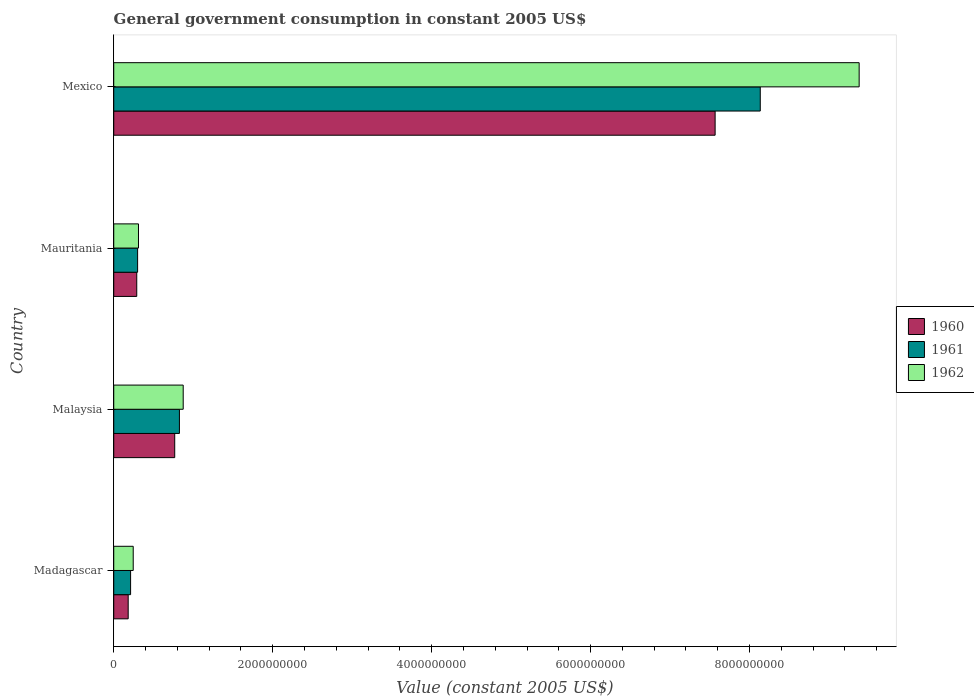How many different coloured bars are there?
Ensure brevity in your answer.  3. Are the number of bars per tick equal to the number of legend labels?
Give a very brief answer. Yes. Are the number of bars on each tick of the Y-axis equal?
Give a very brief answer. Yes. How many bars are there on the 3rd tick from the bottom?
Your answer should be very brief. 3. What is the label of the 3rd group of bars from the top?
Offer a terse response. Malaysia. What is the government conusmption in 1960 in Malaysia?
Provide a short and direct response. 7.67e+08. Across all countries, what is the maximum government conusmption in 1962?
Your answer should be compact. 9.38e+09. Across all countries, what is the minimum government conusmption in 1961?
Offer a terse response. 2.12e+08. In which country was the government conusmption in 1960 minimum?
Your answer should be very brief. Madagascar. What is the total government conusmption in 1962 in the graph?
Your answer should be compact. 1.08e+1. What is the difference between the government conusmption in 1960 in Malaysia and that in Mauritania?
Provide a succinct answer. 4.78e+08. What is the difference between the government conusmption in 1962 in Mauritania and the government conusmption in 1961 in Madagascar?
Your response must be concise. 9.93e+07. What is the average government conusmption in 1962 per country?
Provide a short and direct response. 2.70e+09. What is the difference between the government conusmption in 1962 and government conusmption in 1960 in Mexico?
Make the answer very short. 1.81e+09. What is the ratio of the government conusmption in 1960 in Madagascar to that in Mexico?
Offer a terse response. 0.02. Is the government conusmption in 1961 in Madagascar less than that in Mauritania?
Provide a short and direct response. Yes. Is the difference between the government conusmption in 1962 in Madagascar and Mexico greater than the difference between the government conusmption in 1960 in Madagascar and Mexico?
Provide a short and direct response. No. What is the difference between the highest and the second highest government conusmption in 1961?
Ensure brevity in your answer.  7.31e+09. What is the difference between the highest and the lowest government conusmption in 1962?
Your response must be concise. 9.13e+09. In how many countries, is the government conusmption in 1961 greater than the average government conusmption in 1961 taken over all countries?
Give a very brief answer. 1. What does the 3rd bar from the top in Mexico represents?
Provide a short and direct response. 1960. What does the 3rd bar from the bottom in Madagascar represents?
Keep it short and to the point. 1962. How many bars are there?
Ensure brevity in your answer.  12. Does the graph contain grids?
Give a very brief answer. No. Where does the legend appear in the graph?
Provide a short and direct response. Center right. How many legend labels are there?
Your answer should be very brief. 3. How are the legend labels stacked?
Provide a succinct answer. Vertical. What is the title of the graph?
Keep it short and to the point. General government consumption in constant 2005 US$. Does "1995" appear as one of the legend labels in the graph?
Provide a succinct answer. No. What is the label or title of the X-axis?
Your response must be concise. Value (constant 2005 US$). What is the Value (constant 2005 US$) of 1960 in Madagascar?
Your response must be concise. 1.82e+08. What is the Value (constant 2005 US$) of 1961 in Madagascar?
Provide a short and direct response. 2.12e+08. What is the Value (constant 2005 US$) in 1962 in Madagascar?
Offer a very short reply. 2.45e+08. What is the Value (constant 2005 US$) in 1960 in Malaysia?
Offer a terse response. 7.67e+08. What is the Value (constant 2005 US$) of 1961 in Malaysia?
Give a very brief answer. 8.26e+08. What is the Value (constant 2005 US$) in 1962 in Malaysia?
Make the answer very short. 8.74e+08. What is the Value (constant 2005 US$) in 1960 in Mauritania?
Provide a short and direct response. 2.89e+08. What is the Value (constant 2005 US$) in 1961 in Mauritania?
Your response must be concise. 3.00e+08. What is the Value (constant 2005 US$) of 1962 in Mauritania?
Ensure brevity in your answer.  3.11e+08. What is the Value (constant 2005 US$) of 1960 in Mexico?
Provide a succinct answer. 7.57e+09. What is the Value (constant 2005 US$) in 1961 in Mexico?
Offer a very short reply. 8.13e+09. What is the Value (constant 2005 US$) in 1962 in Mexico?
Provide a succinct answer. 9.38e+09. Across all countries, what is the maximum Value (constant 2005 US$) of 1960?
Ensure brevity in your answer.  7.57e+09. Across all countries, what is the maximum Value (constant 2005 US$) in 1961?
Your answer should be very brief. 8.13e+09. Across all countries, what is the maximum Value (constant 2005 US$) of 1962?
Your answer should be compact. 9.38e+09. Across all countries, what is the minimum Value (constant 2005 US$) in 1960?
Offer a very short reply. 1.82e+08. Across all countries, what is the minimum Value (constant 2005 US$) of 1961?
Give a very brief answer. 2.12e+08. Across all countries, what is the minimum Value (constant 2005 US$) in 1962?
Your answer should be compact. 2.45e+08. What is the total Value (constant 2005 US$) of 1960 in the graph?
Make the answer very short. 8.81e+09. What is the total Value (constant 2005 US$) of 1961 in the graph?
Make the answer very short. 9.47e+09. What is the total Value (constant 2005 US$) of 1962 in the graph?
Provide a succinct answer. 1.08e+1. What is the difference between the Value (constant 2005 US$) of 1960 in Madagascar and that in Malaysia?
Provide a succinct answer. -5.85e+08. What is the difference between the Value (constant 2005 US$) of 1961 in Madagascar and that in Malaysia?
Your answer should be compact. -6.14e+08. What is the difference between the Value (constant 2005 US$) in 1962 in Madagascar and that in Malaysia?
Your response must be concise. -6.29e+08. What is the difference between the Value (constant 2005 US$) in 1960 in Madagascar and that in Mauritania?
Ensure brevity in your answer.  -1.08e+08. What is the difference between the Value (constant 2005 US$) in 1961 in Madagascar and that in Mauritania?
Offer a very short reply. -8.84e+07. What is the difference between the Value (constant 2005 US$) in 1962 in Madagascar and that in Mauritania?
Ensure brevity in your answer.  -6.62e+07. What is the difference between the Value (constant 2005 US$) in 1960 in Madagascar and that in Mexico?
Provide a succinct answer. -7.38e+09. What is the difference between the Value (constant 2005 US$) in 1961 in Madagascar and that in Mexico?
Your answer should be compact. -7.92e+09. What is the difference between the Value (constant 2005 US$) in 1962 in Madagascar and that in Mexico?
Your response must be concise. -9.13e+09. What is the difference between the Value (constant 2005 US$) in 1960 in Malaysia and that in Mauritania?
Offer a very short reply. 4.78e+08. What is the difference between the Value (constant 2005 US$) in 1961 in Malaysia and that in Mauritania?
Provide a succinct answer. 5.26e+08. What is the difference between the Value (constant 2005 US$) of 1962 in Malaysia and that in Mauritania?
Offer a terse response. 5.63e+08. What is the difference between the Value (constant 2005 US$) in 1960 in Malaysia and that in Mexico?
Provide a short and direct response. -6.80e+09. What is the difference between the Value (constant 2005 US$) of 1961 in Malaysia and that in Mexico?
Give a very brief answer. -7.31e+09. What is the difference between the Value (constant 2005 US$) in 1962 in Malaysia and that in Mexico?
Your answer should be compact. -8.50e+09. What is the difference between the Value (constant 2005 US$) of 1960 in Mauritania and that in Mexico?
Ensure brevity in your answer.  -7.28e+09. What is the difference between the Value (constant 2005 US$) in 1961 in Mauritania and that in Mexico?
Make the answer very short. -7.83e+09. What is the difference between the Value (constant 2005 US$) in 1962 in Mauritania and that in Mexico?
Your answer should be compact. -9.07e+09. What is the difference between the Value (constant 2005 US$) in 1960 in Madagascar and the Value (constant 2005 US$) in 1961 in Malaysia?
Your answer should be compact. -6.45e+08. What is the difference between the Value (constant 2005 US$) of 1960 in Madagascar and the Value (constant 2005 US$) of 1962 in Malaysia?
Provide a short and direct response. -6.92e+08. What is the difference between the Value (constant 2005 US$) of 1961 in Madagascar and the Value (constant 2005 US$) of 1962 in Malaysia?
Provide a short and direct response. -6.62e+08. What is the difference between the Value (constant 2005 US$) in 1960 in Madagascar and the Value (constant 2005 US$) in 1961 in Mauritania?
Offer a terse response. -1.19e+08. What is the difference between the Value (constant 2005 US$) in 1960 in Madagascar and the Value (constant 2005 US$) in 1962 in Mauritania?
Your answer should be compact. -1.30e+08. What is the difference between the Value (constant 2005 US$) of 1961 in Madagascar and the Value (constant 2005 US$) of 1962 in Mauritania?
Offer a terse response. -9.93e+07. What is the difference between the Value (constant 2005 US$) in 1960 in Madagascar and the Value (constant 2005 US$) in 1961 in Mexico?
Provide a succinct answer. -7.95e+09. What is the difference between the Value (constant 2005 US$) in 1960 in Madagascar and the Value (constant 2005 US$) in 1962 in Mexico?
Offer a terse response. -9.20e+09. What is the difference between the Value (constant 2005 US$) of 1961 in Madagascar and the Value (constant 2005 US$) of 1962 in Mexico?
Provide a short and direct response. -9.17e+09. What is the difference between the Value (constant 2005 US$) in 1960 in Malaysia and the Value (constant 2005 US$) in 1961 in Mauritania?
Your answer should be very brief. 4.67e+08. What is the difference between the Value (constant 2005 US$) in 1960 in Malaysia and the Value (constant 2005 US$) in 1962 in Mauritania?
Provide a short and direct response. 4.56e+08. What is the difference between the Value (constant 2005 US$) in 1961 in Malaysia and the Value (constant 2005 US$) in 1962 in Mauritania?
Provide a short and direct response. 5.15e+08. What is the difference between the Value (constant 2005 US$) in 1960 in Malaysia and the Value (constant 2005 US$) in 1961 in Mexico?
Offer a terse response. -7.37e+09. What is the difference between the Value (constant 2005 US$) of 1960 in Malaysia and the Value (constant 2005 US$) of 1962 in Mexico?
Keep it short and to the point. -8.61e+09. What is the difference between the Value (constant 2005 US$) in 1961 in Malaysia and the Value (constant 2005 US$) in 1962 in Mexico?
Provide a succinct answer. -8.55e+09. What is the difference between the Value (constant 2005 US$) of 1960 in Mauritania and the Value (constant 2005 US$) of 1961 in Mexico?
Provide a succinct answer. -7.85e+09. What is the difference between the Value (constant 2005 US$) in 1960 in Mauritania and the Value (constant 2005 US$) in 1962 in Mexico?
Offer a very short reply. -9.09e+09. What is the difference between the Value (constant 2005 US$) of 1961 in Mauritania and the Value (constant 2005 US$) of 1962 in Mexico?
Give a very brief answer. -9.08e+09. What is the average Value (constant 2005 US$) in 1960 per country?
Make the answer very short. 2.20e+09. What is the average Value (constant 2005 US$) in 1961 per country?
Give a very brief answer. 2.37e+09. What is the average Value (constant 2005 US$) in 1962 per country?
Provide a succinct answer. 2.70e+09. What is the difference between the Value (constant 2005 US$) in 1960 and Value (constant 2005 US$) in 1961 in Madagascar?
Your answer should be very brief. -3.02e+07. What is the difference between the Value (constant 2005 US$) in 1960 and Value (constant 2005 US$) in 1962 in Madagascar?
Provide a succinct answer. -6.34e+07. What is the difference between the Value (constant 2005 US$) in 1961 and Value (constant 2005 US$) in 1962 in Madagascar?
Provide a short and direct response. -3.32e+07. What is the difference between the Value (constant 2005 US$) of 1960 and Value (constant 2005 US$) of 1961 in Malaysia?
Give a very brief answer. -5.92e+07. What is the difference between the Value (constant 2005 US$) in 1960 and Value (constant 2005 US$) in 1962 in Malaysia?
Your response must be concise. -1.07e+08. What is the difference between the Value (constant 2005 US$) in 1961 and Value (constant 2005 US$) in 1962 in Malaysia?
Ensure brevity in your answer.  -4.75e+07. What is the difference between the Value (constant 2005 US$) in 1960 and Value (constant 2005 US$) in 1961 in Mauritania?
Ensure brevity in your answer.  -1.09e+07. What is the difference between the Value (constant 2005 US$) of 1960 and Value (constant 2005 US$) of 1962 in Mauritania?
Your response must be concise. -2.18e+07. What is the difference between the Value (constant 2005 US$) of 1961 and Value (constant 2005 US$) of 1962 in Mauritania?
Provide a short and direct response. -1.09e+07. What is the difference between the Value (constant 2005 US$) in 1960 and Value (constant 2005 US$) in 1961 in Mexico?
Provide a succinct answer. -5.68e+08. What is the difference between the Value (constant 2005 US$) in 1960 and Value (constant 2005 US$) in 1962 in Mexico?
Ensure brevity in your answer.  -1.81e+09. What is the difference between the Value (constant 2005 US$) in 1961 and Value (constant 2005 US$) in 1962 in Mexico?
Keep it short and to the point. -1.24e+09. What is the ratio of the Value (constant 2005 US$) of 1960 in Madagascar to that in Malaysia?
Keep it short and to the point. 0.24. What is the ratio of the Value (constant 2005 US$) of 1961 in Madagascar to that in Malaysia?
Ensure brevity in your answer.  0.26. What is the ratio of the Value (constant 2005 US$) in 1962 in Madagascar to that in Malaysia?
Your response must be concise. 0.28. What is the ratio of the Value (constant 2005 US$) of 1960 in Madagascar to that in Mauritania?
Ensure brevity in your answer.  0.63. What is the ratio of the Value (constant 2005 US$) of 1961 in Madagascar to that in Mauritania?
Offer a terse response. 0.71. What is the ratio of the Value (constant 2005 US$) in 1962 in Madagascar to that in Mauritania?
Offer a very short reply. 0.79. What is the ratio of the Value (constant 2005 US$) of 1960 in Madagascar to that in Mexico?
Ensure brevity in your answer.  0.02. What is the ratio of the Value (constant 2005 US$) in 1961 in Madagascar to that in Mexico?
Your answer should be compact. 0.03. What is the ratio of the Value (constant 2005 US$) of 1962 in Madagascar to that in Mexico?
Provide a succinct answer. 0.03. What is the ratio of the Value (constant 2005 US$) in 1960 in Malaysia to that in Mauritania?
Offer a very short reply. 2.65. What is the ratio of the Value (constant 2005 US$) of 1961 in Malaysia to that in Mauritania?
Offer a very short reply. 2.75. What is the ratio of the Value (constant 2005 US$) of 1962 in Malaysia to that in Mauritania?
Your answer should be very brief. 2.81. What is the ratio of the Value (constant 2005 US$) in 1960 in Malaysia to that in Mexico?
Offer a terse response. 0.1. What is the ratio of the Value (constant 2005 US$) of 1961 in Malaysia to that in Mexico?
Your response must be concise. 0.1. What is the ratio of the Value (constant 2005 US$) in 1962 in Malaysia to that in Mexico?
Give a very brief answer. 0.09. What is the ratio of the Value (constant 2005 US$) in 1960 in Mauritania to that in Mexico?
Your response must be concise. 0.04. What is the ratio of the Value (constant 2005 US$) in 1961 in Mauritania to that in Mexico?
Make the answer very short. 0.04. What is the ratio of the Value (constant 2005 US$) in 1962 in Mauritania to that in Mexico?
Your response must be concise. 0.03. What is the difference between the highest and the second highest Value (constant 2005 US$) in 1960?
Ensure brevity in your answer.  6.80e+09. What is the difference between the highest and the second highest Value (constant 2005 US$) of 1961?
Your answer should be very brief. 7.31e+09. What is the difference between the highest and the second highest Value (constant 2005 US$) in 1962?
Give a very brief answer. 8.50e+09. What is the difference between the highest and the lowest Value (constant 2005 US$) of 1960?
Give a very brief answer. 7.38e+09. What is the difference between the highest and the lowest Value (constant 2005 US$) of 1961?
Offer a very short reply. 7.92e+09. What is the difference between the highest and the lowest Value (constant 2005 US$) in 1962?
Your answer should be very brief. 9.13e+09. 